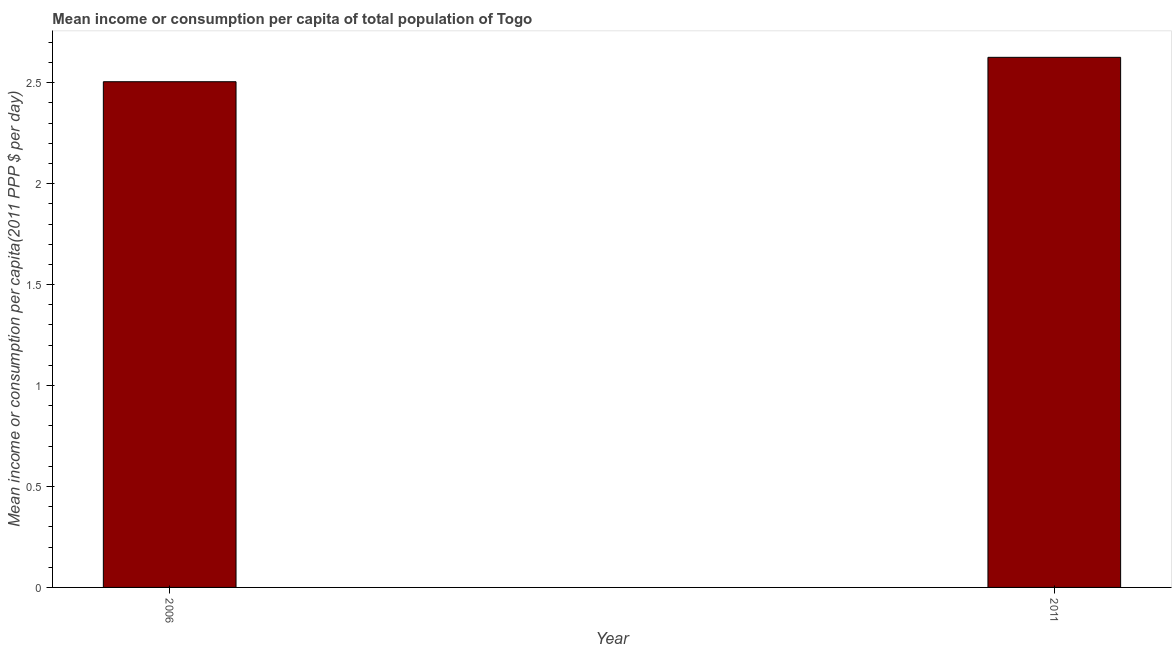Does the graph contain any zero values?
Your answer should be compact. No. Does the graph contain grids?
Make the answer very short. No. What is the title of the graph?
Provide a succinct answer. Mean income or consumption per capita of total population of Togo. What is the label or title of the X-axis?
Offer a terse response. Year. What is the label or title of the Y-axis?
Ensure brevity in your answer.  Mean income or consumption per capita(2011 PPP $ per day). What is the mean income or consumption in 2011?
Offer a terse response. 2.63. Across all years, what is the maximum mean income or consumption?
Your answer should be very brief. 2.63. Across all years, what is the minimum mean income or consumption?
Give a very brief answer. 2.5. In which year was the mean income or consumption minimum?
Your answer should be compact. 2006. What is the sum of the mean income or consumption?
Make the answer very short. 5.13. What is the difference between the mean income or consumption in 2006 and 2011?
Ensure brevity in your answer.  -0.12. What is the average mean income or consumption per year?
Offer a terse response. 2.56. What is the median mean income or consumption?
Give a very brief answer. 2.57. Do a majority of the years between 2011 and 2006 (inclusive) have mean income or consumption greater than 1.4 $?
Offer a very short reply. No. What is the ratio of the mean income or consumption in 2006 to that in 2011?
Ensure brevity in your answer.  0.95. Is the mean income or consumption in 2006 less than that in 2011?
Provide a short and direct response. Yes. In how many years, is the mean income or consumption greater than the average mean income or consumption taken over all years?
Make the answer very short. 1. How many years are there in the graph?
Your answer should be very brief. 2. What is the difference between two consecutive major ticks on the Y-axis?
Offer a terse response. 0.5. Are the values on the major ticks of Y-axis written in scientific E-notation?
Your answer should be compact. No. What is the Mean income or consumption per capita(2011 PPP $ per day) in 2006?
Offer a terse response. 2.5. What is the Mean income or consumption per capita(2011 PPP $ per day) in 2011?
Offer a very short reply. 2.63. What is the difference between the Mean income or consumption per capita(2011 PPP $ per day) in 2006 and 2011?
Make the answer very short. -0.12. What is the ratio of the Mean income or consumption per capita(2011 PPP $ per day) in 2006 to that in 2011?
Make the answer very short. 0.95. 